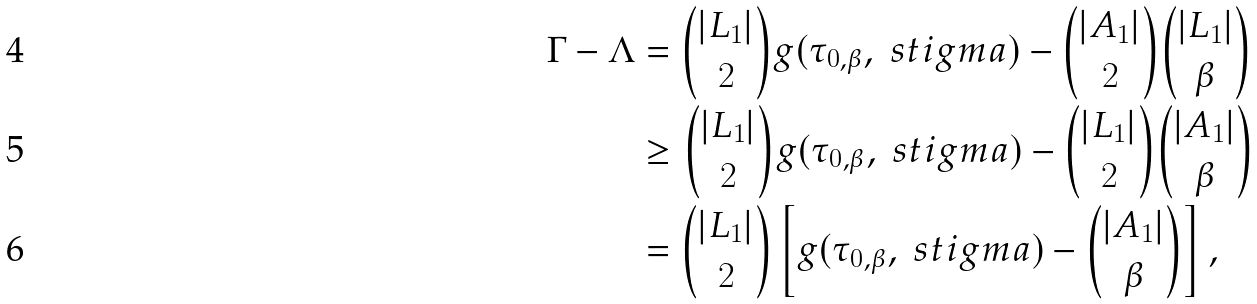Convert formula to latex. <formula><loc_0><loc_0><loc_500><loc_500>\Gamma - \Lambda & = \binom { | L _ { 1 } | } { 2 } g ( \tau _ { 0 , \beta } , \ s t i g m a ) - \binom { | A _ { 1 } | } { 2 } \binom { | L _ { 1 } | } { \beta } \\ & \geq \binom { | L _ { 1 } | } { 2 } g ( \tau _ { 0 , \beta } , \ s t i g m a ) - \binom { | L _ { 1 } | } { 2 } \binom { | A _ { 1 } | } { \beta } \\ & = \binom { | L _ { 1 } | } { 2 } \left [ g ( \tau _ { 0 , \beta } , \ s t i g m a ) - \binom { | A _ { 1 } | } { \beta } \right ] , \,</formula> 